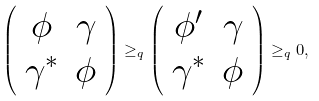<formula> <loc_0><loc_0><loc_500><loc_500>\left ( \begin{array} { c c } \phi & \gamma \\ \gamma ^ { * } & \phi \end{array} \right ) \geq _ { q } \left ( \begin{array} { c c } \phi ^ { \prime } & \gamma \\ \gamma ^ { * } & \phi \end{array} \right ) \geq _ { q } 0 ,</formula> 